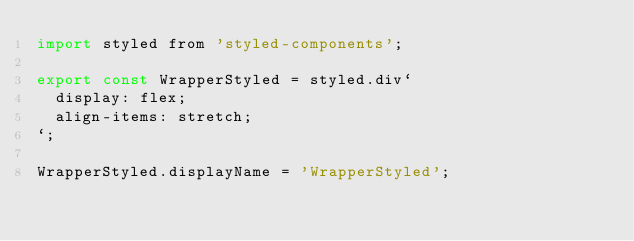Convert code to text. <code><loc_0><loc_0><loc_500><loc_500><_JavaScript_>import styled from 'styled-components';

export const WrapperStyled = styled.div`
  display: flex;
  align-items: stretch;
`;

WrapperStyled.displayName = 'WrapperStyled';
</code> 